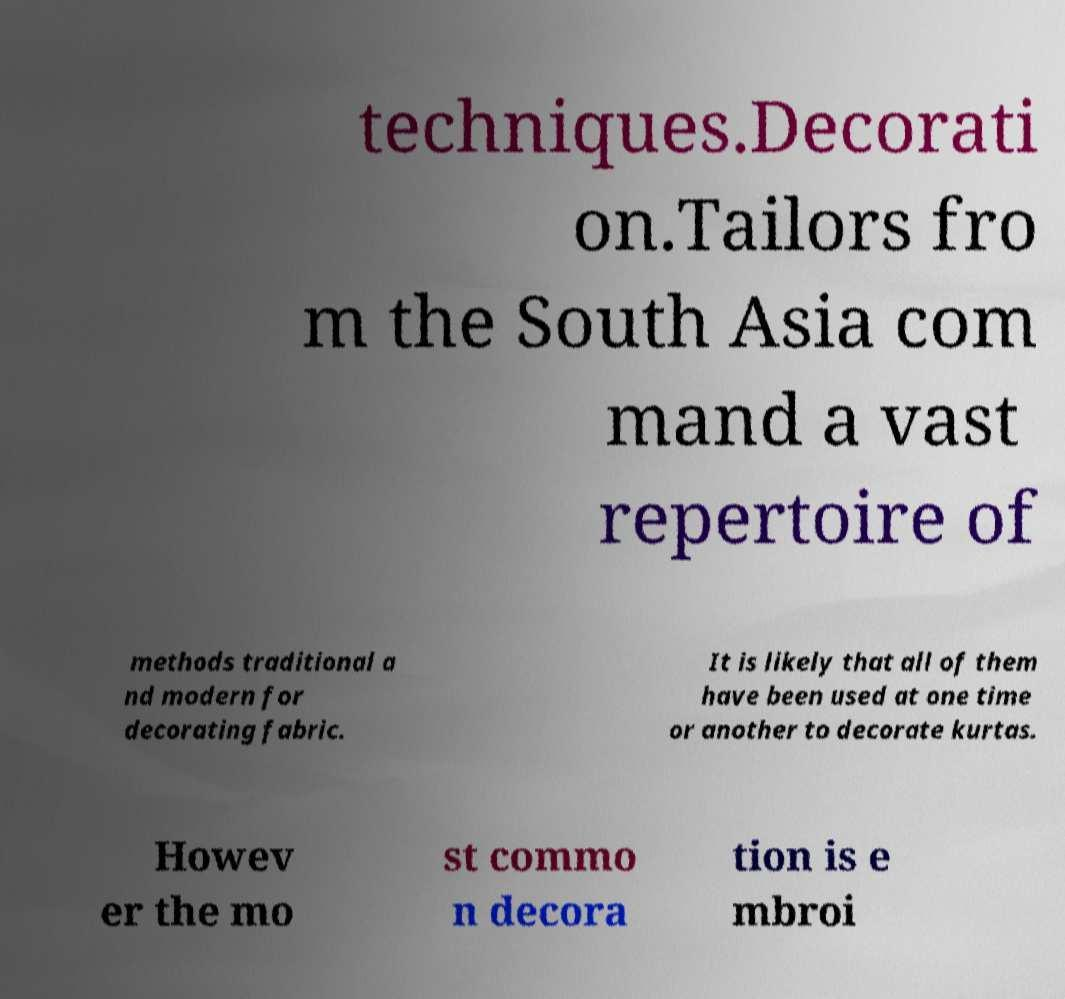Could you extract and type out the text from this image? techniques.Decorati on.Tailors fro m the South Asia com mand a vast repertoire of methods traditional a nd modern for decorating fabric. It is likely that all of them have been used at one time or another to decorate kurtas. Howev er the mo st commo n decora tion is e mbroi 